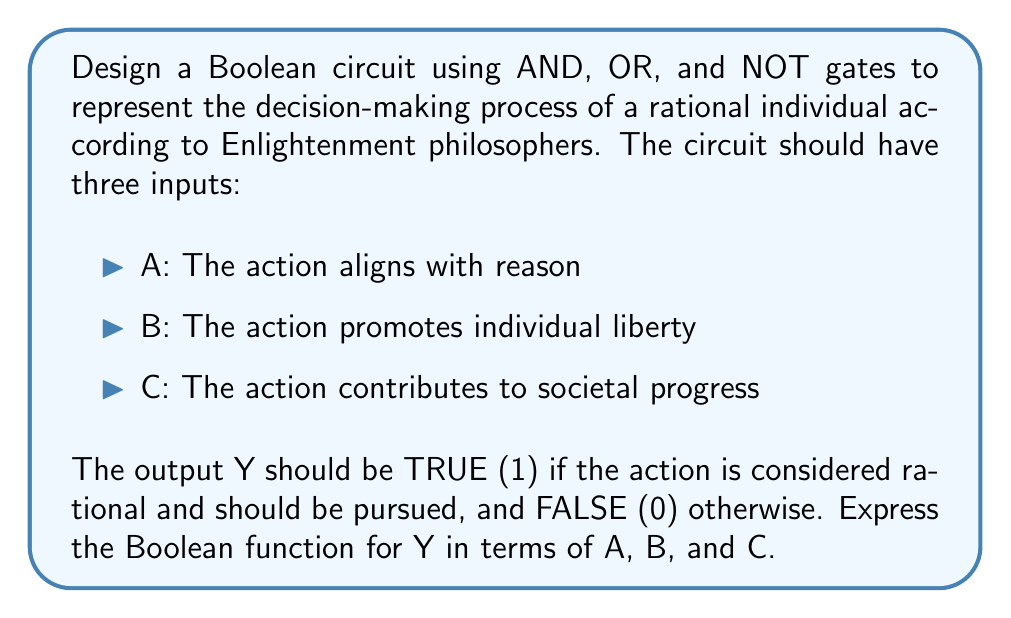Solve this math problem. To design this Boolean circuit, we need to consider the key principles of Enlightenment philosophy:

1. Reason is paramount in decision-making.
2. Individual liberty is highly valued.
3. Actions should contribute to societal progress.

We can represent these principles using the following logic:

1. The action must align with reason (A must be true).
2. The action should either promote individual liberty (B) OR contribute to societal progress (C).

We can express this logic using Boolean algebra:

$$Y = A \cdot (B + C)$$

where $\cdot$ represents AND, and $+$ represents OR.

To implement this using basic logic gates:

1. Use an OR gate to combine inputs B and C: $$(B + C)$$
2. Use an AND gate to combine the result of step 1 with input A: $$A \cdot (B + C)$$

The circuit diagram would look like this:

[asy]
import geometry;

// Define points
pair A = (0,0), B = (0,40), C = (0,80);
pair OR = (60,60), AND = (120,30);
pair Y = (180,30);

// Draw input lines
draw(A--shift(30,0)*A, arrow=Arrow(TeXHead));
draw(B--OR, arrow=Arrow(TeXHead));
draw(C--OR, arrow=Arrow(TeXHead));

// Draw OR gate
draw(OR--shift(30,-20)*OR--shift(30,20)*OR--OR);
draw(arc(OR, 20, -90, 90));

// Draw AND gate
draw(AND--shift(30,-20)*AND--shift(30,20)*AND--AND);
draw(arc(shift(30,0)*AND, 20, 180, 360));

// Draw connection and output
draw(OR--shift(90,-30)*OR, arrow=Arrow(TeXHead));
draw(shift(30,0)*A--shift(90,0)*A--AND, arrow=Arrow(TeXHead));
draw(AND--Y, arrow=Arrow(TeXHead));

// Label points
label("A", A, W);
label("B", B, W);
label("C", C, W);
label("Y", Y, E);
label("OR", OR, NE);
label("AND", AND, S);
[/asy]

This circuit implements the Boolean function $$Y = A \cdot (B + C)$$

which represents the decision-making process of a rational individual according to Enlightenment principles.
Answer: $Y = A \cdot (B + C)$ 